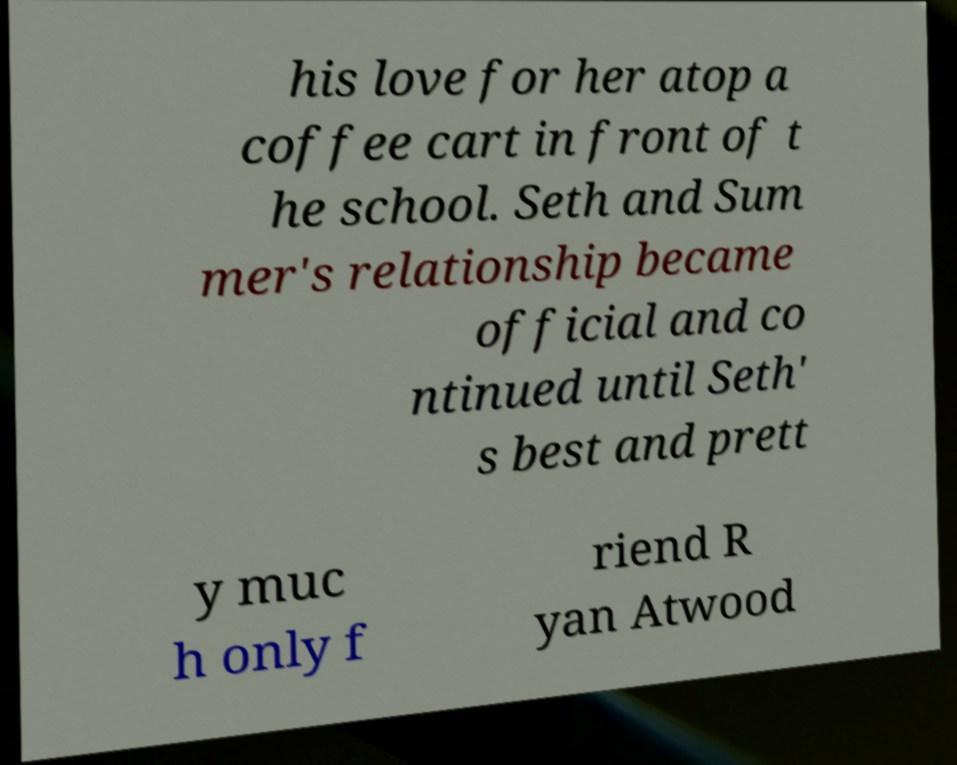There's text embedded in this image that I need extracted. Can you transcribe it verbatim? his love for her atop a coffee cart in front of t he school. Seth and Sum mer's relationship became official and co ntinued until Seth' s best and prett y muc h only f riend R yan Atwood 